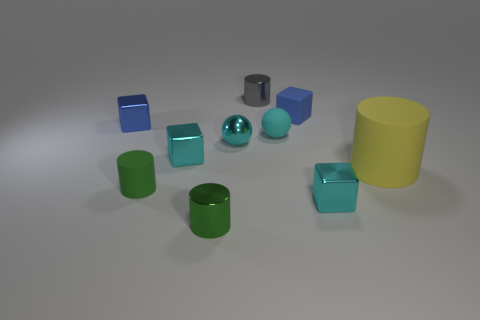Subtract all blue rubber blocks. How many blocks are left? 3 Subtract all green blocks. Subtract all red cylinders. How many blocks are left? 4 Subtract all balls. How many objects are left? 8 Subtract 0 red spheres. How many objects are left? 10 Subtract all large gray shiny blocks. Subtract all big matte cylinders. How many objects are left? 9 Add 5 blue cubes. How many blue cubes are left? 7 Add 2 blue objects. How many blue objects exist? 4 